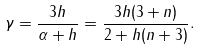<formula> <loc_0><loc_0><loc_500><loc_500>\gamma = \frac { 3 h } { \alpha + h } = \frac { 3 h ( 3 + n ) } { 2 + h ( n + 3 ) } .</formula> 